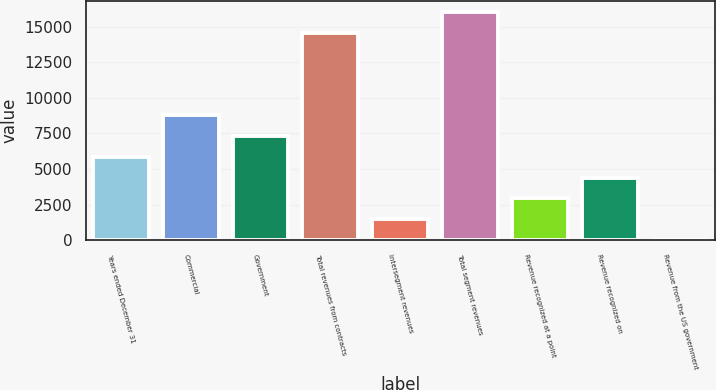Convert chart to OTSL. <chart><loc_0><loc_0><loc_500><loc_500><bar_chart><fcel>Years ended December 31<fcel>Commercial<fcel>Government<fcel>Total revenues from contracts<fcel>Intersegment revenues<fcel>Total segment revenues<fcel>Revenue recognized at a point<fcel>Revenue recognized on<fcel>Revenue from the US government<nl><fcel>5855.8<fcel>8764.2<fcel>7310<fcel>14532<fcel>1493.2<fcel>15986.2<fcel>2947.4<fcel>4401.6<fcel>39<nl></chart> 